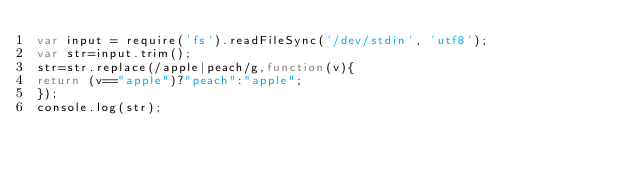Convert code to text. <code><loc_0><loc_0><loc_500><loc_500><_JavaScript_>var input = require('fs').readFileSync('/dev/stdin', 'utf8');
var str=input.trim();
str=str.replace(/apple|peach/g,function(v){
return (v=="apple")?"peach":"apple";
});
console.log(str);</code> 